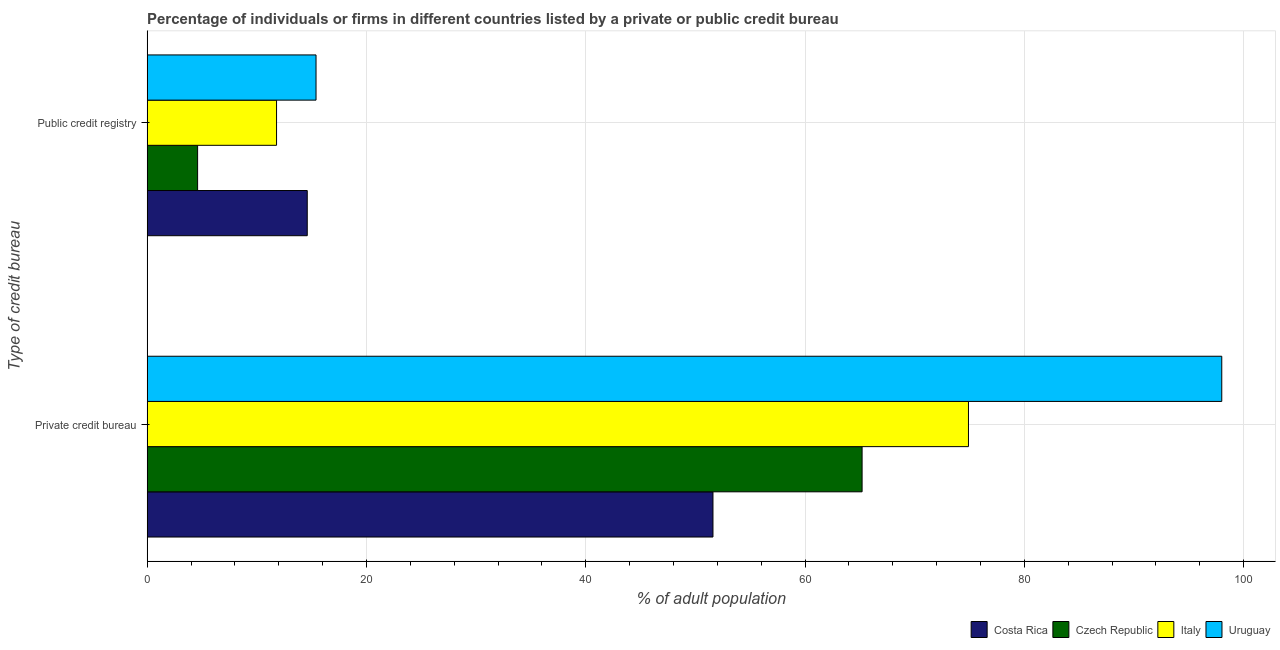How many different coloured bars are there?
Your answer should be compact. 4. Are the number of bars on each tick of the Y-axis equal?
Keep it short and to the point. Yes. What is the label of the 1st group of bars from the top?
Keep it short and to the point. Public credit registry. What is the percentage of firms listed by private credit bureau in Costa Rica?
Provide a short and direct response. 51.6. Across all countries, what is the minimum percentage of firms listed by private credit bureau?
Offer a terse response. 51.6. In which country was the percentage of firms listed by public credit bureau maximum?
Keep it short and to the point. Uruguay. In which country was the percentage of firms listed by public credit bureau minimum?
Ensure brevity in your answer.  Czech Republic. What is the total percentage of firms listed by public credit bureau in the graph?
Ensure brevity in your answer.  46.4. What is the difference between the percentage of firms listed by private credit bureau in Costa Rica and that in Czech Republic?
Offer a terse response. -13.6. What is the difference between the percentage of firms listed by public credit bureau in Costa Rica and the percentage of firms listed by private credit bureau in Czech Republic?
Give a very brief answer. -50.6. What is the average percentage of firms listed by private credit bureau per country?
Ensure brevity in your answer.  72.43. What is the difference between the percentage of firms listed by private credit bureau and percentage of firms listed by public credit bureau in Costa Rica?
Your answer should be very brief. 37. What is the ratio of the percentage of firms listed by public credit bureau in Italy to that in Costa Rica?
Provide a succinct answer. 0.81. Is the percentage of firms listed by public credit bureau in Uruguay less than that in Czech Republic?
Offer a very short reply. No. In how many countries, is the percentage of firms listed by private credit bureau greater than the average percentage of firms listed by private credit bureau taken over all countries?
Keep it short and to the point. 2. What does the 4th bar from the bottom in Public credit registry represents?
Give a very brief answer. Uruguay. How many countries are there in the graph?
Provide a short and direct response. 4. Does the graph contain any zero values?
Your response must be concise. No. Where does the legend appear in the graph?
Your response must be concise. Bottom right. How are the legend labels stacked?
Offer a very short reply. Horizontal. What is the title of the graph?
Your answer should be compact. Percentage of individuals or firms in different countries listed by a private or public credit bureau. Does "Upper middle income" appear as one of the legend labels in the graph?
Ensure brevity in your answer.  No. What is the label or title of the X-axis?
Offer a terse response. % of adult population. What is the label or title of the Y-axis?
Give a very brief answer. Type of credit bureau. What is the % of adult population of Costa Rica in Private credit bureau?
Your answer should be compact. 51.6. What is the % of adult population in Czech Republic in Private credit bureau?
Provide a short and direct response. 65.2. What is the % of adult population of Italy in Private credit bureau?
Your answer should be compact. 74.9. What is the % of adult population of Czech Republic in Public credit registry?
Provide a succinct answer. 4.6. Across all Type of credit bureau, what is the maximum % of adult population in Costa Rica?
Your answer should be very brief. 51.6. Across all Type of credit bureau, what is the maximum % of adult population in Czech Republic?
Ensure brevity in your answer.  65.2. Across all Type of credit bureau, what is the maximum % of adult population of Italy?
Your answer should be compact. 74.9. Across all Type of credit bureau, what is the maximum % of adult population in Uruguay?
Give a very brief answer. 98. Across all Type of credit bureau, what is the minimum % of adult population in Czech Republic?
Offer a terse response. 4.6. Across all Type of credit bureau, what is the minimum % of adult population in Uruguay?
Provide a short and direct response. 15.4. What is the total % of adult population in Costa Rica in the graph?
Your answer should be compact. 66.2. What is the total % of adult population of Czech Republic in the graph?
Offer a terse response. 69.8. What is the total % of adult population in Italy in the graph?
Provide a short and direct response. 86.7. What is the total % of adult population in Uruguay in the graph?
Your answer should be very brief. 113.4. What is the difference between the % of adult population in Czech Republic in Private credit bureau and that in Public credit registry?
Make the answer very short. 60.6. What is the difference between the % of adult population of Italy in Private credit bureau and that in Public credit registry?
Make the answer very short. 63.1. What is the difference between the % of adult population in Uruguay in Private credit bureau and that in Public credit registry?
Offer a very short reply. 82.6. What is the difference between the % of adult population in Costa Rica in Private credit bureau and the % of adult population in Italy in Public credit registry?
Offer a terse response. 39.8. What is the difference between the % of adult population of Costa Rica in Private credit bureau and the % of adult population of Uruguay in Public credit registry?
Provide a short and direct response. 36.2. What is the difference between the % of adult population of Czech Republic in Private credit bureau and the % of adult population of Italy in Public credit registry?
Give a very brief answer. 53.4. What is the difference between the % of adult population of Czech Republic in Private credit bureau and the % of adult population of Uruguay in Public credit registry?
Make the answer very short. 49.8. What is the difference between the % of adult population of Italy in Private credit bureau and the % of adult population of Uruguay in Public credit registry?
Ensure brevity in your answer.  59.5. What is the average % of adult population of Costa Rica per Type of credit bureau?
Your answer should be compact. 33.1. What is the average % of adult population of Czech Republic per Type of credit bureau?
Offer a terse response. 34.9. What is the average % of adult population in Italy per Type of credit bureau?
Make the answer very short. 43.35. What is the average % of adult population in Uruguay per Type of credit bureau?
Your answer should be compact. 56.7. What is the difference between the % of adult population in Costa Rica and % of adult population in Czech Republic in Private credit bureau?
Your response must be concise. -13.6. What is the difference between the % of adult population in Costa Rica and % of adult population in Italy in Private credit bureau?
Keep it short and to the point. -23.3. What is the difference between the % of adult population of Costa Rica and % of adult population of Uruguay in Private credit bureau?
Your answer should be compact. -46.4. What is the difference between the % of adult population in Czech Republic and % of adult population in Italy in Private credit bureau?
Provide a succinct answer. -9.7. What is the difference between the % of adult population of Czech Republic and % of adult population of Uruguay in Private credit bureau?
Give a very brief answer. -32.8. What is the difference between the % of adult population of Italy and % of adult population of Uruguay in Private credit bureau?
Your answer should be very brief. -23.1. What is the difference between the % of adult population in Costa Rica and % of adult population in Czech Republic in Public credit registry?
Offer a very short reply. 10. What is the difference between the % of adult population in Costa Rica and % of adult population in Uruguay in Public credit registry?
Your response must be concise. -0.8. What is the difference between the % of adult population of Czech Republic and % of adult population of Uruguay in Public credit registry?
Make the answer very short. -10.8. What is the ratio of the % of adult population in Costa Rica in Private credit bureau to that in Public credit registry?
Give a very brief answer. 3.53. What is the ratio of the % of adult population of Czech Republic in Private credit bureau to that in Public credit registry?
Keep it short and to the point. 14.17. What is the ratio of the % of adult population of Italy in Private credit bureau to that in Public credit registry?
Ensure brevity in your answer.  6.35. What is the ratio of the % of adult population of Uruguay in Private credit bureau to that in Public credit registry?
Make the answer very short. 6.36. What is the difference between the highest and the second highest % of adult population of Czech Republic?
Offer a very short reply. 60.6. What is the difference between the highest and the second highest % of adult population in Italy?
Your answer should be compact. 63.1. What is the difference between the highest and the second highest % of adult population of Uruguay?
Offer a very short reply. 82.6. What is the difference between the highest and the lowest % of adult population in Costa Rica?
Your response must be concise. 37. What is the difference between the highest and the lowest % of adult population of Czech Republic?
Ensure brevity in your answer.  60.6. What is the difference between the highest and the lowest % of adult population of Italy?
Provide a short and direct response. 63.1. What is the difference between the highest and the lowest % of adult population of Uruguay?
Your answer should be compact. 82.6. 